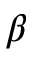<formula> <loc_0><loc_0><loc_500><loc_500>\beta</formula> 